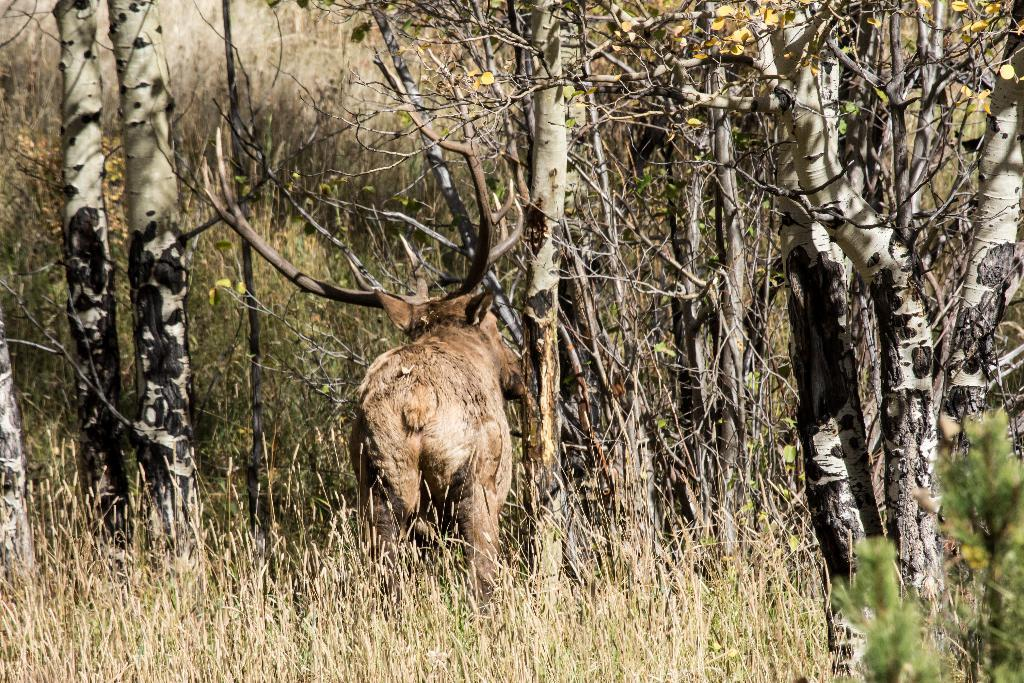What type of vegetation can be seen in the image? There is grass and trees in the image. Can you describe the animal in the image? The animal in the image is cream and brown in color. What is the condition of some of the leaves on the trees? Some leaves of the trees are yellow in color. Where is the drum located in the image? There is no drum present in the image. What type of brush can be seen in the image? There is no brush present in the image. 